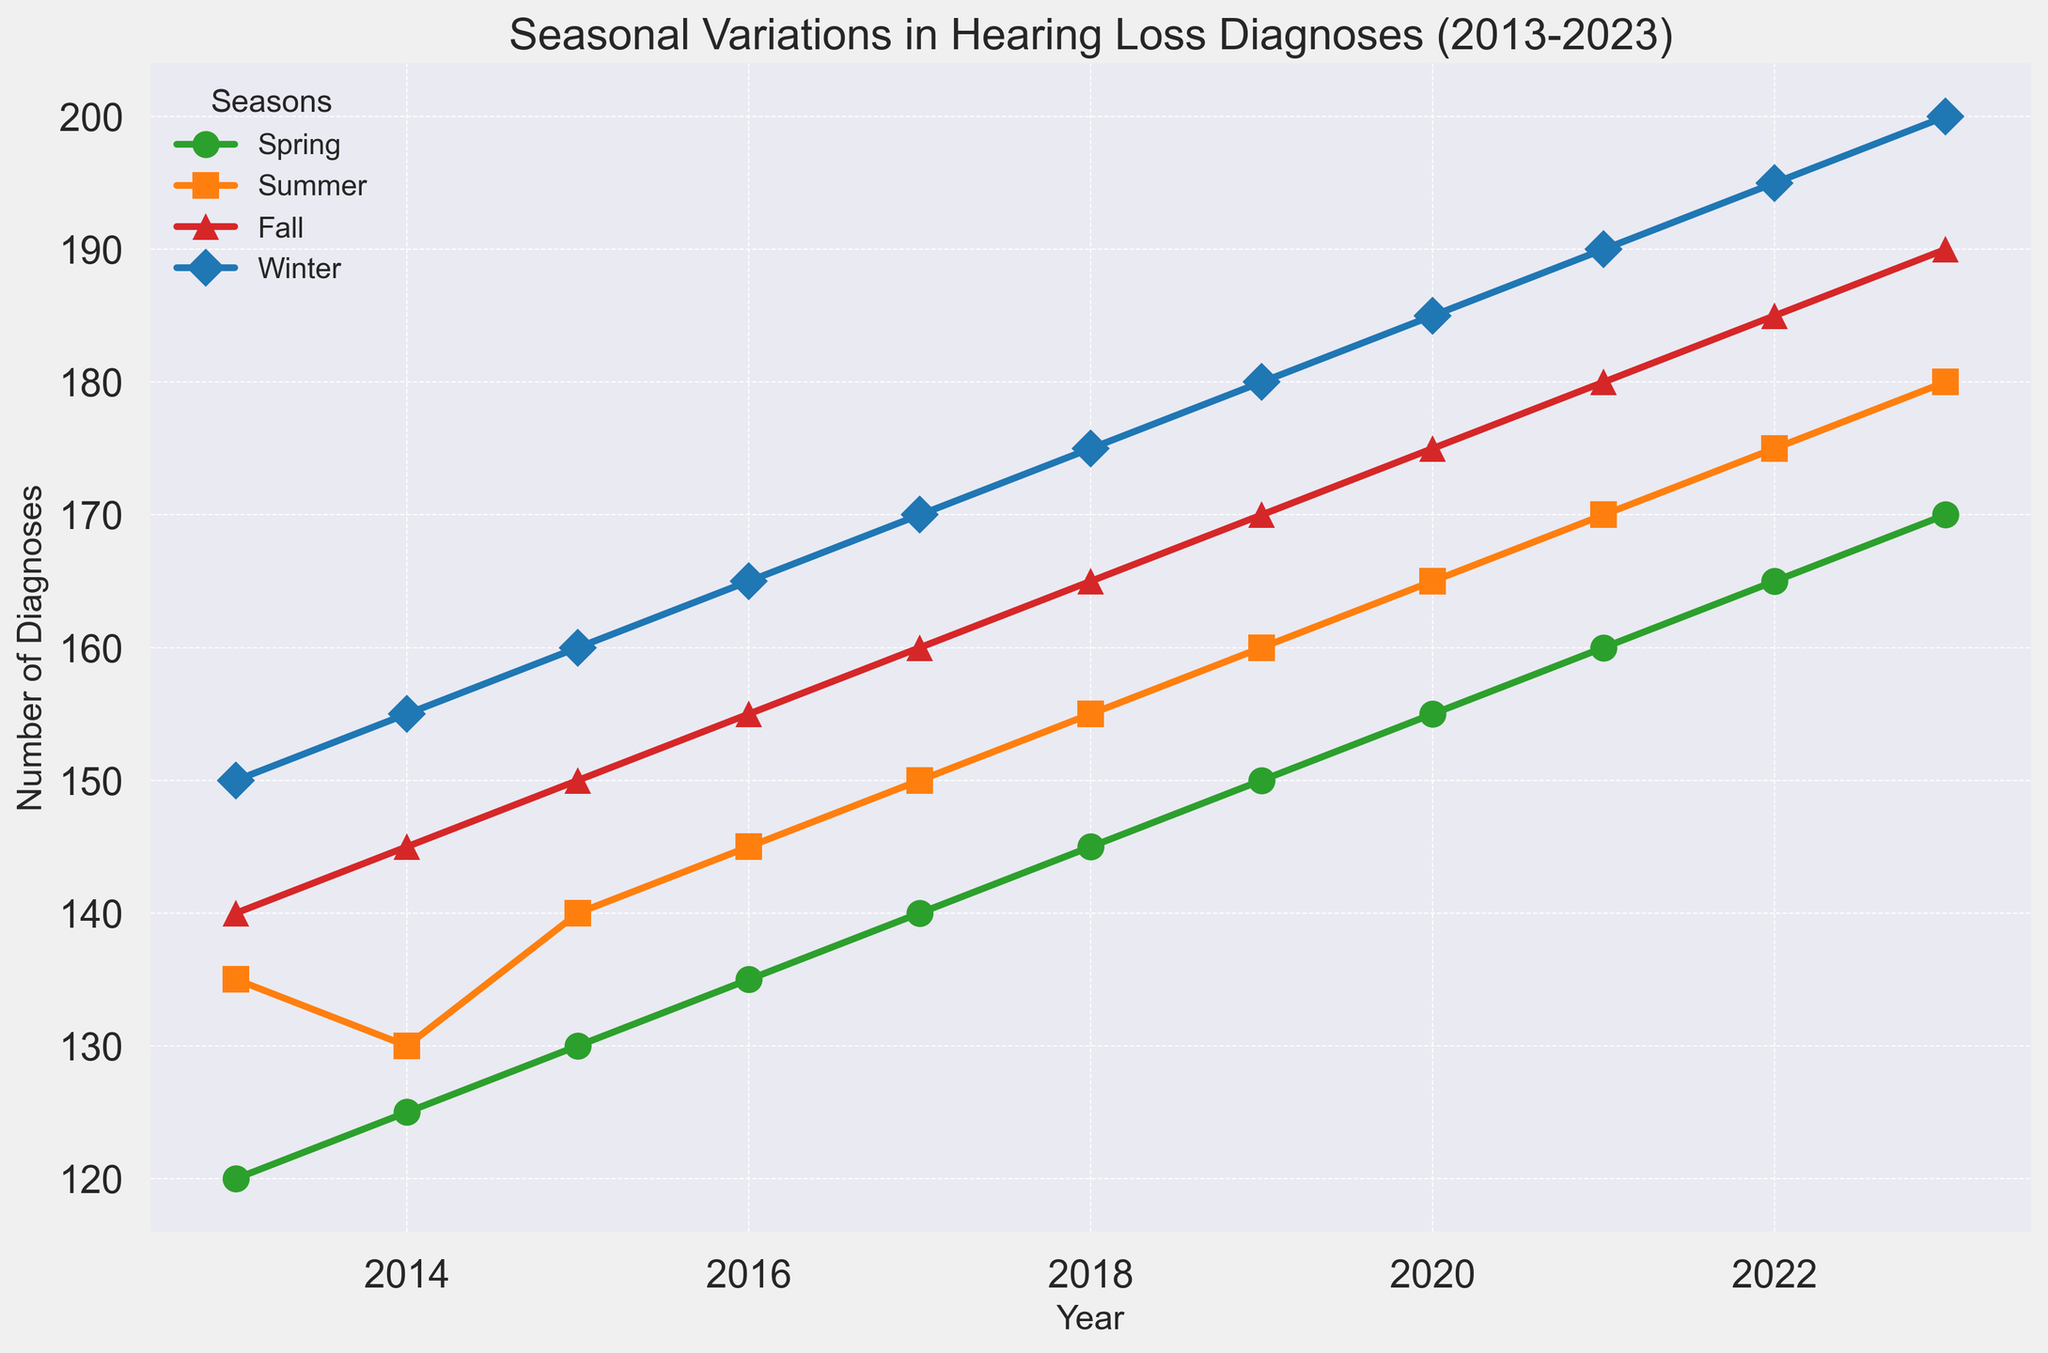Why does Winter consistently have the highest number of diagnoses each year from 2013 to 2023? Each year's line for Winter is above the other three seasons consistently across all years, indicating that the number of diagnoses in Winter is the highest every year.
Answer: It was the highest every year Which year has the greatest increase in diagnoses from Spring to Summer? To find this, calculate the difference between the Summer and Spring values for each year. The greatest difference is seen in 2023, with Summer having 10 more diagnoses than Spring.
Answer: 2023 What is the average number of diagnoses in Fall over the decade? Add the Fall diagnoses from each year, then divide by the number of years (11). The total is (140 + 145 + 150 + 155 + 160 + 165 + 170 + 175 + 180 + 185 + 190) = 1815. The average is 1815/11 = 165.
Answer: 165 In which year do Spring and Fall have the least difference in diagnoses? Calculate the absolute difference between Spring and Fall for each year. The smallest absolute difference is in 2014 with a difference of 20 (145 - 125).
Answer: 2014 Which season shows the most consistent increase in diagnoses over the years? By examining the trend lines, Winter shows the most consistent and steady increase, with the line having a uniform upwards slope across all years.
Answer: Winter How many more diagnoses were recorded in Winter 2023 compared to Winter 2013? Subtract Winter 2013 diagnoses from Winter 2023 diagnoses. 200 - 150 = 50 more diagnoses in 2023.
Answer: 50 Which year has the highest number of total diagnoses for all seasons combined? Calculate the total diagnoses per year by summing all seasons. For 2023, total diagnoses = (170 + 180 + 190 + 200) = 740, which is the highest.
Answer: 2023 What is the trend in diagnoses for Summer from 2013 to 2023? The total diagnoses for Summer steadily increase each year. This is seen by following the upward slope of Summer’s line from 135 in 2013 to 180 in 2023.
Answer: Increasing trend Which two consecutive years had the smallest increase in the number of diagnoses in the Spring season? Calculate the year-to-year difference for Spring diagnoses. The smallest increase is from 2022 to 2023, with an increase of 5 diagnoses (170 - 165).
Answer: 2022-2023 